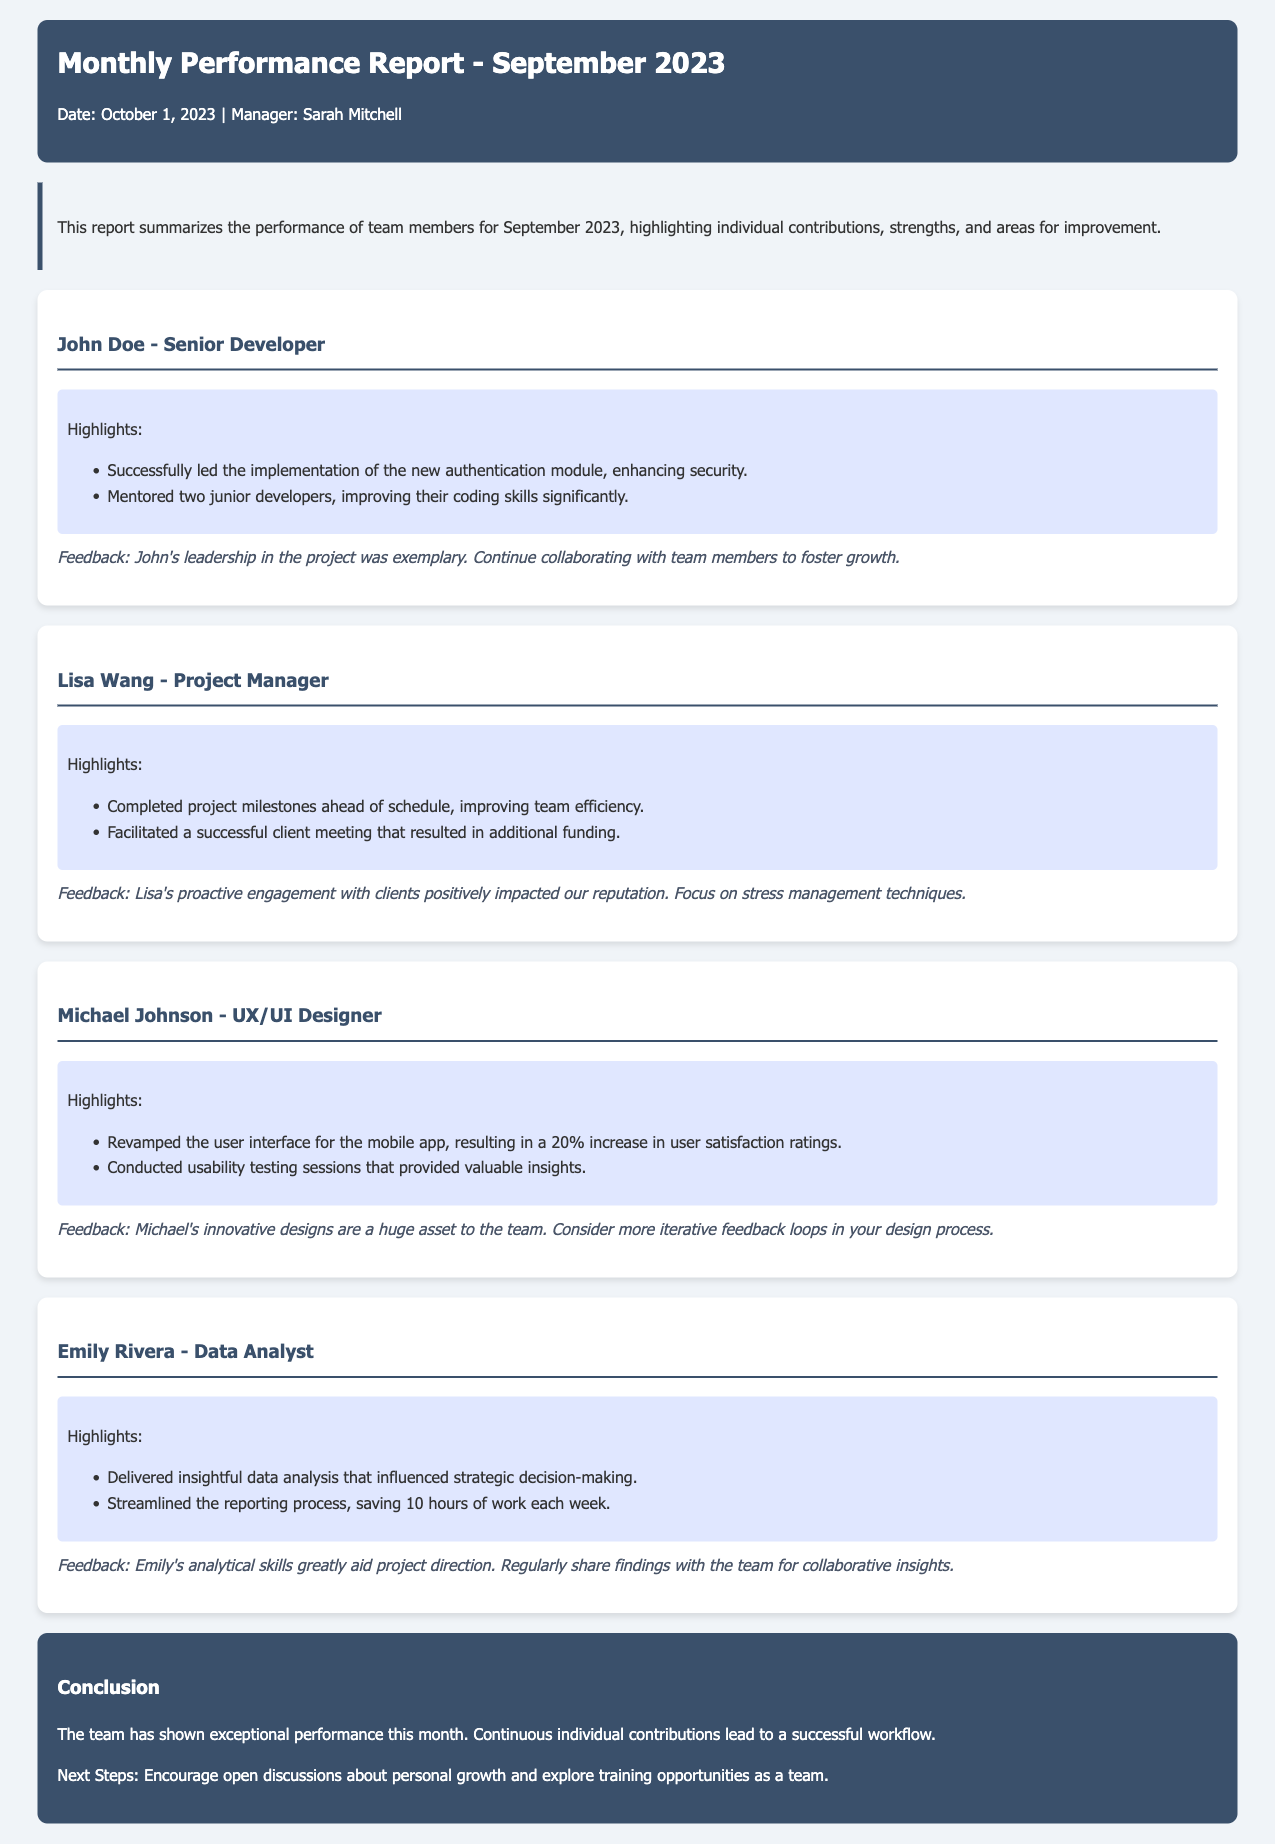What is the date of the report? The date of the report is stated clearly in the header section as October 1, 2023.
Answer: October 1, 2023 Who is the Project Manager? The Project Manager is mentioned in the document under the team members section, Lisa Wang.
Answer: Lisa Wang What was the user satisfaction rating increase achieved by Michael Johnson? The document states that Michael's design led to a 20% increase in user satisfaction ratings.
Answer: 20% What is the focus area for John's continuous improvement? The feedback section suggests that John should continue collaborating with team members to foster growth.
Answer: Collaborating with team members How many hours did Emily save in the reporting process weekly? The document mentions that Emily streamlined the reporting process, saving 10 hours of work each week.
Answer: 10 hours What role does Michael Johnson hold in the team? The team member's title is given prominently as UX/UI Designer.
Answer: UX/UI Designer What is the main conclusion of the report? The conclusion summarizes the performance and states that the team has shown exceptional performance.
Answer: Exceptional performance What are the next steps suggested in the report? The next steps focus on encouraging open discussions about personal growth and exploring training opportunities as a team.
Answer: Open discussions and training opportunities 